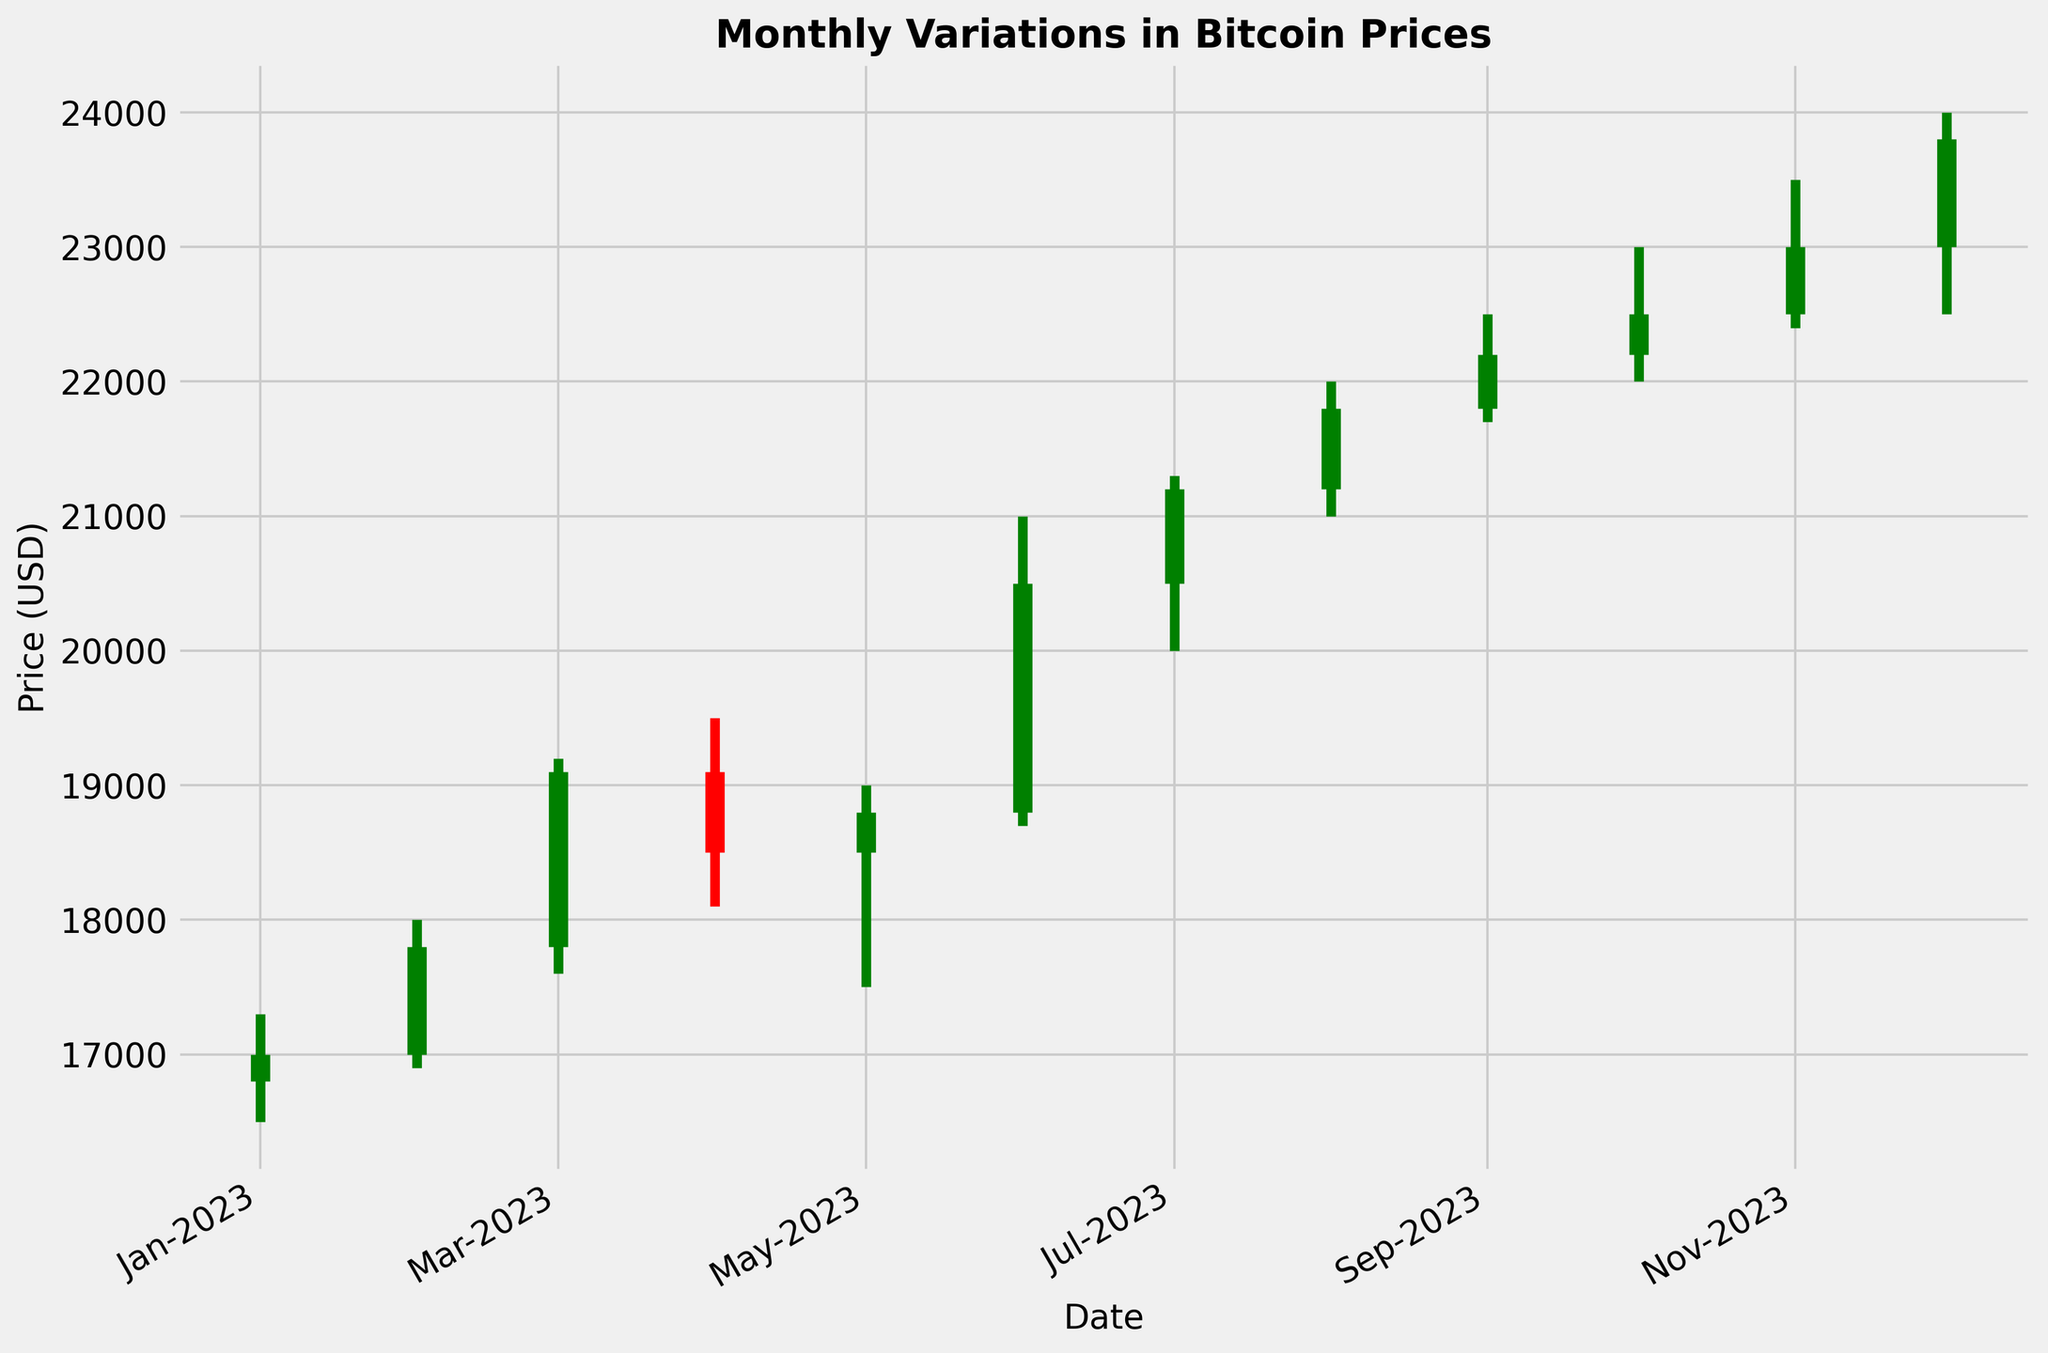What month had the highest closing price? To identify the month with the highest closing price, we look for the tallest candlestick on the plot and check the topmost point of its thick middle section.
Answer: December 2023 Did cryptocurrencies end higher or lower than they started in June 2023? In June 2023, the plot shows a green candlestick where the closing price is higher than the opening price, indicated by a thick green bar extending upwards.
Answer: Higher What is the overall trend from January 2023 to December 2023? To determine the overall trend, compare the closing prices from January and December. A consistent increase each month signals an upward trend.
Answer: Upward Which month shows the greatest difference between the high and low prices? By visually inspecting the length of the vertical lines on each candlestick, we identify the month with the longest vertical line segment.
Answer: June 2023 Compare the opening prices for January and February 2023. Which one is higher? To determine which opening price is higher, check the starting points of the thick middle sections of January (16800) and February (17000) on the y-axis.
Answer: February Did the price always close higher than the opening price from August 2023 to December 2023? From August to December, check the candlestick colors: green indicates a closing price higher than the opening, and red indicates a closing price lower than the opening. They are all green.
Answer: Yes What is the largest drop in closing price from one month to the next? To find the largest monthly drop, calculate the difference between consecutive closing prices and identify the largest negative value. The drop from March (19100) to April (18500) is the largest at 600.
Answer: 600 What is the median closing price over the year? To find the median closing price, order the closing prices: [17000, 17800, 18500, 18800, 19100, 20500, 21200, 21800, 22200, 22500, 23000, 23800]. The middle values are 20500 and 21200. The median is the average of these two.
Answer: 20850 How many months had closing prices higher than 20,000 USD? Count the months where the top of the thick middle section of the candlestick is above the 20,000 USD mark on the y-axis.
Answer: 6 months 